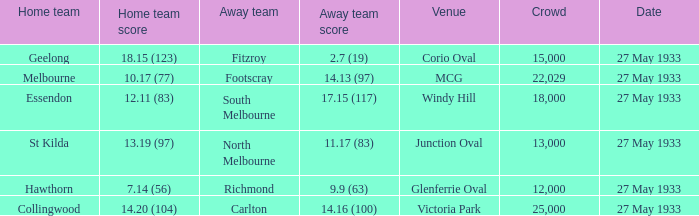In the game where the visiting team scored 15000.0. 